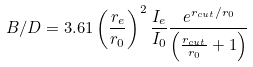<formula> <loc_0><loc_0><loc_500><loc_500>B / D = 3 . 6 1 \left ( \frac { r _ { e } } { r _ { 0 } } \right ) ^ { 2 } \frac { I _ { e } } { I _ { 0 } } \frac { e ^ { r _ { c u t } / r _ { 0 } } } { \left ( \frac { r _ { c u t } } { r _ { 0 } } + 1 \right ) }</formula> 